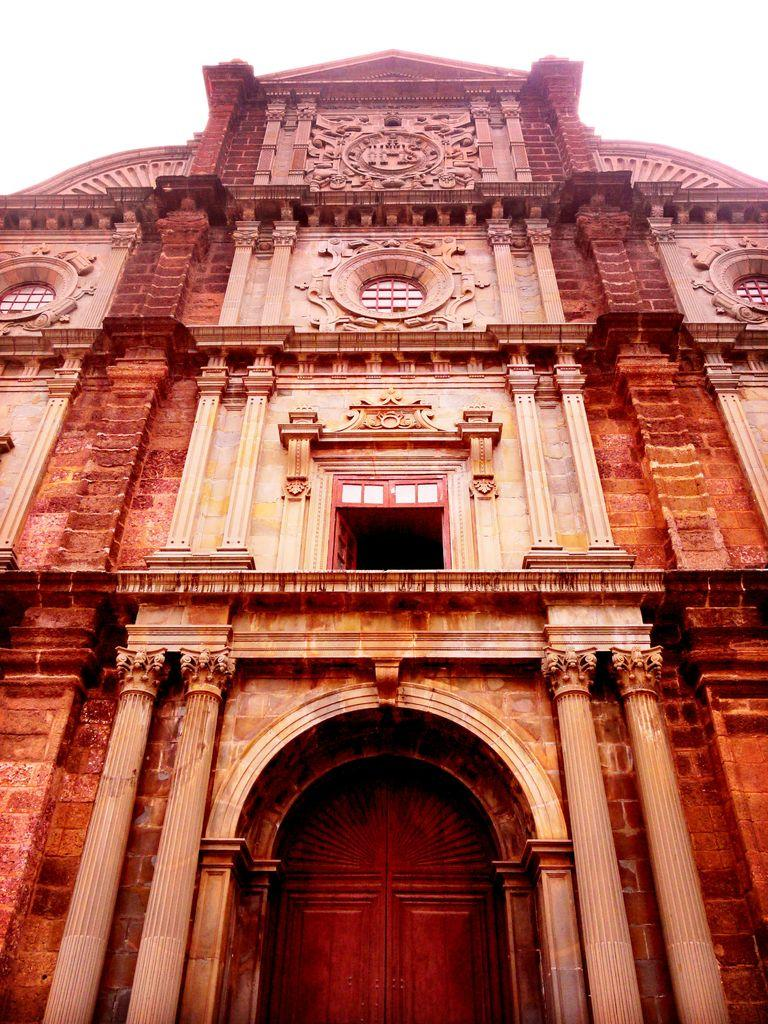What is the main subject in the center of the image? There is a building in the center of the image. What architectural features can be seen in the image? There are pillars in the image. What is visible at the top of the image? The sky is visible at the top of the image. What type of bun is being used to hold the building together in the image? There is no bun present in the image; it is a building with pillars. What voice can be heard coming from the building in the image? There is no voice or sound present in the image; it is a static image of a building. 